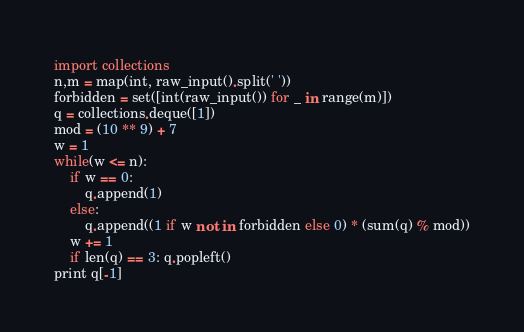<code> <loc_0><loc_0><loc_500><loc_500><_Python_>import collections
n,m = map(int, raw_input().split(' '))
forbidden = set([int(raw_input()) for _ in range(m)])
q = collections.deque([1])
mod = (10 ** 9) + 7
w = 1
while(w <= n):
	if w == 0:
		q.append(1)
	else:
		q.append((1 if w not in forbidden else 0) * (sum(q) % mod))
	w += 1
	if len(q) == 3: q.popleft() 
print q[-1]</code> 